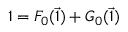<formula> <loc_0><loc_0><loc_500><loc_500>1 = F _ { 0 } ( \vec { 1 } ) + G _ { 0 } ( \vec { 1 } )</formula> 